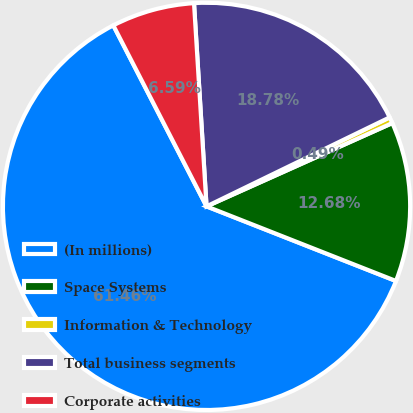Convert chart. <chart><loc_0><loc_0><loc_500><loc_500><pie_chart><fcel>(In millions)<fcel>Space Systems<fcel>Information & Technology<fcel>Total business segments<fcel>Corporate activities<nl><fcel>61.46%<fcel>12.68%<fcel>0.49%<fcel>18.78%<fcel>6.59%<nl></chart> 